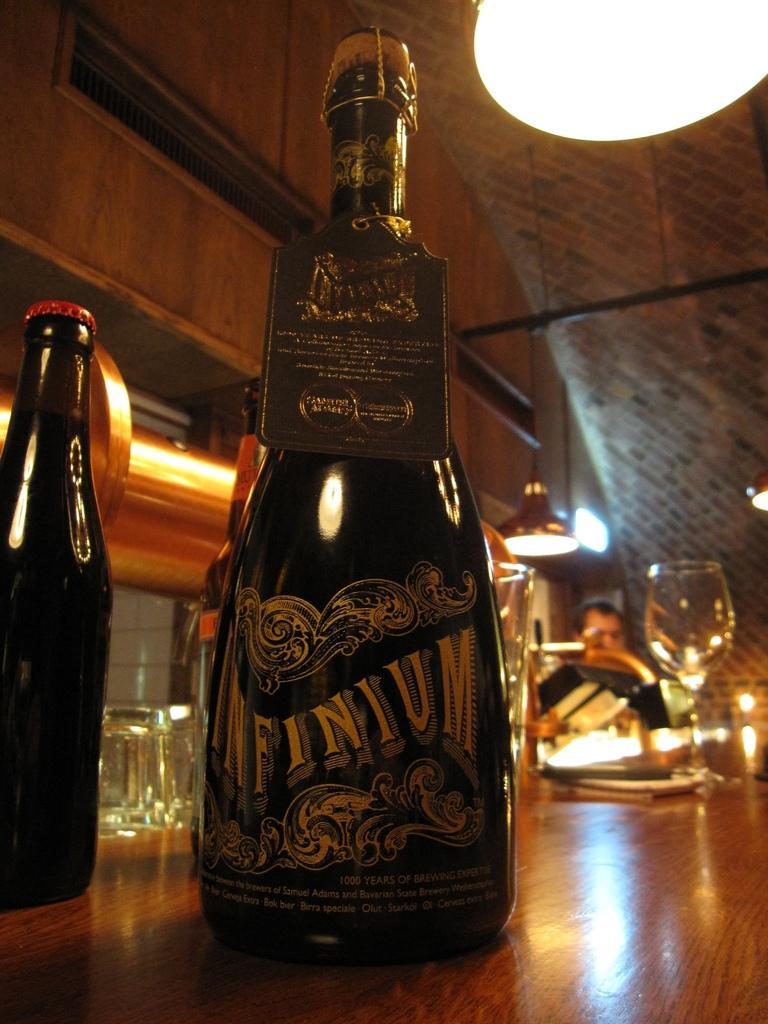Could you give a brief overview of what you see in this image? In this image we can see a bottle with label and rubber stopper is placed on the wooden table. Here we can see another bottle and glasses are also placed on the table. The background of the image is slightly blurred, where we can see a person,ceiling lamps, wooden wall and the brick ceiling. 